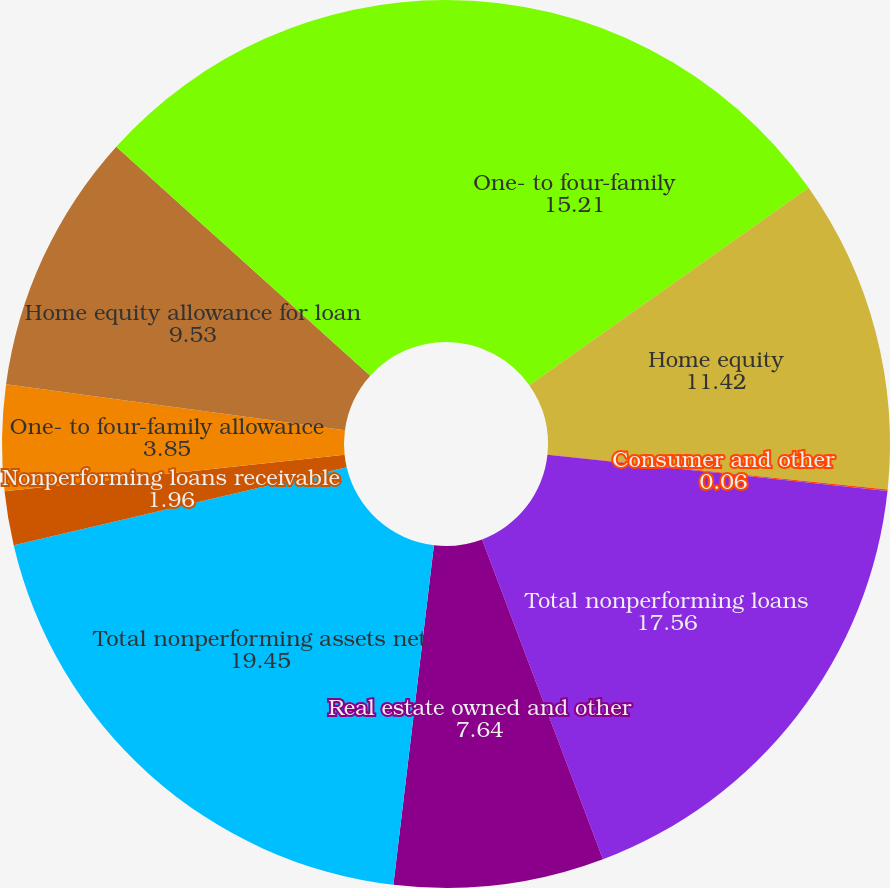Convert chart to OTSL. <chart><loc_0><loc_0><loc_500><loc_500><pie_chart><fcel>One- to four-family<fcel>Home equity<fcel>Consumer and other<fcel>Total nonperforming loans<fcel>Real estate owned and other<fcel>Total nonperforming assets net<fcel>Nonperforming loans receivable<fcel>One- to four-family allowance<fcel>Home equity allowance for loan<fcel>Consumer and other allowance<nl><fcel>15.21%<fcel>11.42%<fcel>0.06%<fcel>17.56%<fcel>7.64%<fcel>19.45%<fcel>1.96%<fcel>3.85%<fcel>9.53%<fcel>13.32%<nl></chart> 